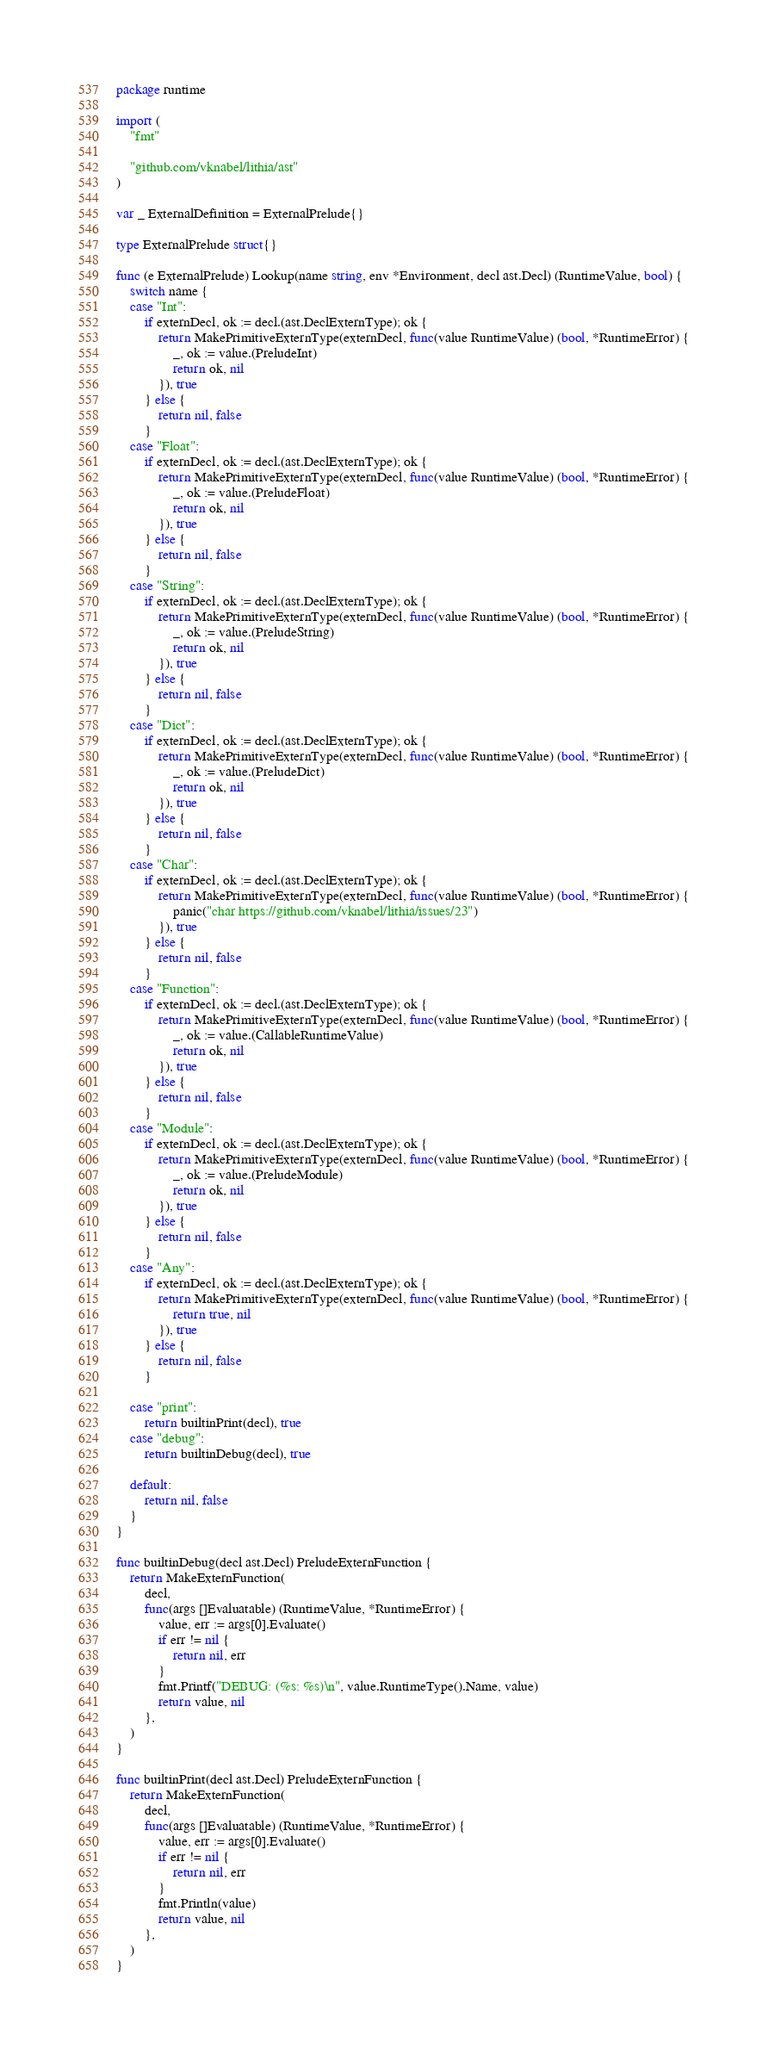<code> <loc_0><loc_0><loc_500><loc_500><_Go_>package runtime

import (
	"fmt"

	"github.com/vknabel/lithia/ast"
)

var _ ExternalDefinition = ExternalPrelude{}

type ExternalPrelude struct{}

func (e ExternalPrelude) Lookup(name string, env *Environment, decl ast.Decl) (RuntimeValue, bool) {
	switch name {
	case "Int":
		if externDecl, ok := decl.(ast.DeclExternType); ok {
			return MakePrimitiveExternType(externDecl, func(value RuntimeValue) (bool, *RuntimeError) {
				_, ok := value.(PreludeInt)
				return ok, nil
			}), true
		} else {
			return nil, false
		}
	case "Float":
		if externDecl, ok := decl.(ast.DeclExternType); ok {
			return MakePrimitiveExternType(externDecl, func(value RuntimeValue) (bool, *RuntimeError) {
				_, ok := value.(PreludeFloat)
				return ok, nil
			}), true
		} else {
			return nil, false
		}
	case "String":
		if externDecl, ok := decl.(ast.DeclExternType); ok {
			return MakePrimitiveExternType(externDecl, func(value RuntimeValue) (bool, *RuntimeError) {
				_, ok := value.(PreludeString)
				return ok, nil
			}), true
		} else {
			return nil, false
		}
	case "Dict":
		if externDecl, ok := decl.(ast.DeclExternType); ok {
			return MakePrimitiveExternType(externDecl, func(value RuntimeValue) (bool, *RuntimeError) {
				_, ok := value.(PreludeDict)
				return ok, nil
			}), true
		} else {
			return nil, false
		}
	case "Char":
		if externDecl, ok := decl.(ast.DeclExternType); ok {
			return MakePrimitiveExternType(externDecl, func(value RuntimeValue) (bool, *RuntimeError) {
				panic("char https://github.com/vknabel/lithia/issues/23")
			}), true
		} else {
			return nil, false
		}
	case "Function":
		if externDecl, ok := decl.(ast.DeclExternType); ok {
			return MakePrimitiveExternType(externDecl, func(value RuntimeValue) (bool, *RuntimeError) {
				_, ok := value.(CallableRuntimeValue)
				return ok, nil
			}), true
		} else {
			return nil, false
		}
	case "Module":
		if externDecl, ok := decl.(ast.DeclExternType); ok {
			return MakePrimitiveExternType(externDecl, func(value RuntimeValue) (bool, *RuntimeError) {
				_, ok := value.(PreludeModule)
				return ok, nil
			}), true
		} else {
			return nil, false
		}
	case "Any":
		if externDecl, ok := decl.(ast.DeclExternType); ok {
			return MakePrimitiveExternType(externDecl, func(value RuntimeValue) (bool, *RuntimeError) {
				return true, nil
			}), true
		} else {
			return nil, false
		}

	case "print":
		return builtinPrint(decl), true
	case "debug":
		return builtinDebug(decl), true

	default:
		return nil, false
	}
}

func builtinDebug(decl ast.Decl) PreludeExternFunction {
	return MakeExternFunction(
		decl,
		func(args []Evaluatable) (RuntimeValue, *RuntimeError) {
			value, err := args[0].Evaluate()
			if err != nil {
				return nil, err
			}
			fmt.Printf("DEBUG: (%s: %s)\n", value.RuntimeType().Name, value)
			return value, nil
		},
	)
}

func builtinPrint(decl ast.Decl) PreludeExternFunction {
	return MakeExternFunction(
		decl,
		func(args []Evaluatable) (RuntimeValue, *RuntimeError) {
			value, err := args[0].Evaluate()
			if err != nil {
				return nil, err
			}
			fmt.Println(value)
			return value, nil
		},
	)
}
</code> 